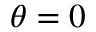Convert formula to latex. <formula><loc_0><loc_0><loc_500><loc_500>\theta = 0</formula> 